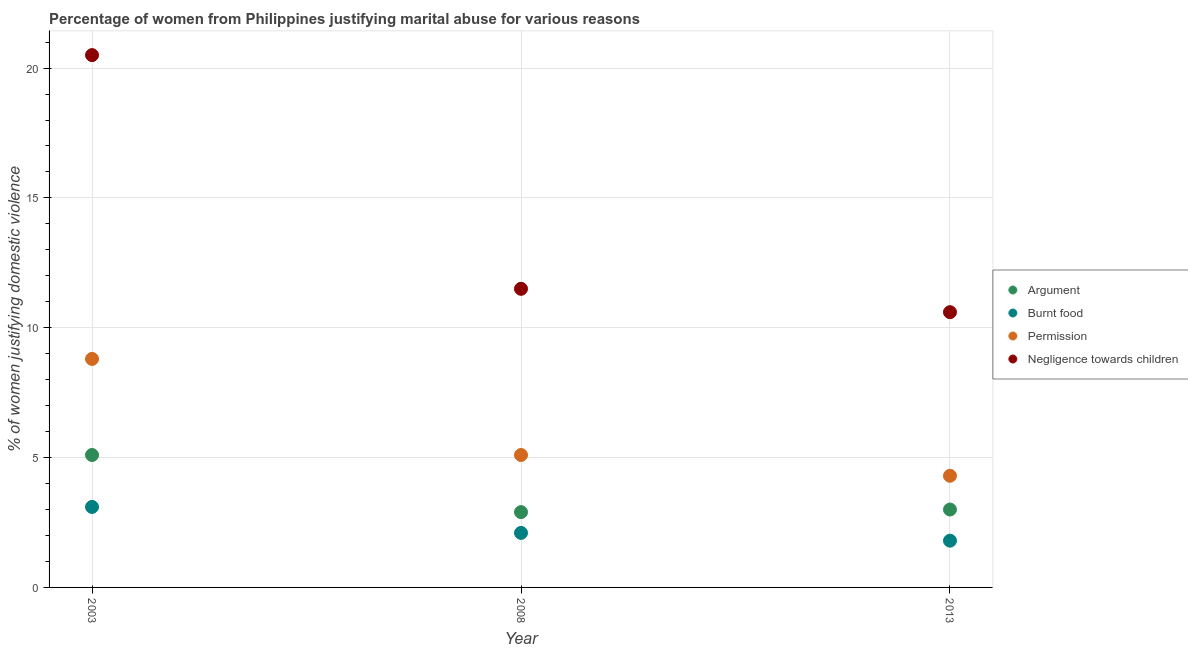What is the percentage of women justifying abuse for going without permission in 2013?
Provide a short and direct response. 4.3. Across all years, what is the maximum percentage of women justifying abuse for showing negligence towards children?
Offer a terse response. 20.5. Across all years, what is the minimum percentage of women justifying abuse in the case of an argument?
Give a very brief answer. 2.9. In which year was the percentage of women justifying abuse for burning food maximum?
Offer a very short reply. 2003. In which year was the percentage of women justifying abuse in the case of an argument minimum?
Ensure brevity in your answer.  2008. What is the total percentage of women justifying abuse for showing negligence towards children in the graph?
Provide a succinct answer. 42.6. What is the difference between the percentage of women justifying abuse for showing negligence towards children in 2008 and that in 2013?
Keep it short and to the point. 0.9. What is the difference between the percentage of women justifying abuse for showing negligence towards children in 2003 and the percentage of women justifying abuse for going without permission in 2008?
Offer a very short reply. 15.4. What is the average percentage of women justifying abuse in the case of an argument per year?
Ensure brevity in your answer.  3.67. In the year 2003, what is the difference between the percentage of women justifying abuse for going without permission and percentage of women justifying abuse for burning food?
Provide a succinct answer. 5.7. What is the ratio of the percentage of women justifying abuse for burning food in 2003 to that in 2008?
Offer a very short reply. 1.48. Is the percentage of women justifying abuse for going without permission in 2003 less than that in 2008?
Make the answer very short. No. Is the difference between the percentage of women justifying abuse for going without permission in 2008 and 2013 greater than the difference between the percentage of women justifying abuse in the case of an argument in 2008 and 2013?
Offer a very short reply. Yes. Is the sum of the percentage of women justifying abuse for showing negligence towards children in 2003 and 2008 greater than the maximum percentage of women justifying abuse for going without permission across all years?
Your answer should be compact. Yes. Is it the case that in every year, the sum of the percentage of women justifying abuse in the case of an argument and percentage of women justifying abuse for burning food is greater than the percentage of women justifying abuse for going without permission?
Keep it short and to the point. No. Does the percentage of women justifying abuse for burning food monotonically increase over the years?
Your response must be concise. No. Are the values on the major ticks of Y-axis written in scientific E-notation?
Give a very brief answer. No. Does the graph contain any zero values?
Your response must be concise. No. Where does the legend appear in the graph?
Make the answer very short. Center right. How many legend labels are there?
Provide a short and direct response. 4. What is the title of the graph?
Make the answer very short. Percentage of women from Philippines justifying marital abuse for various reasons. Does "Budget management" appear as one of the legend labels in the graph?
Your answer should be compact. No. What is the label or title of the X-axis?
Your answer should be compact. Year. What is the label or title of the Y-axis?
Ensure brevity in your answer.  % of women justifying domestic violence. What is the % of women justifying domestic violence in Argument in 2003?
Make the answer very short. 5.1. What is the % of women justifying domestic violence in Burnt food in 2003?
Provide a short and direct response. 3.1. What is the % of women justifying domestic violence in Argument in 2008?
Provide a succinct answer. 2.9. What is the % of women justifying domestic violence in Burnt food in 2008?
Give a very brief answer. 2.1. What is the % of women justifying domestic violence in Negligence towards children in 2008?
Offer a very short reply. 11.5. What is the % of women justifying domestic violence of Burnt food in 2013?
Offer a terse response. 1.8. Across all years, what is the maximum % of women justifying domestic violence of Argument?
Provide a short and direct response. 5.1. Across all years, what is the maximum % of women justifying domestic violence in Burnt food?
Your answer should be very brief. 3.1. Across all years, what is the maximum % of women justifying domestic violence in Permission?
Your response must be concise. 8.8. Across all years, what is the maximum % of women justifying domestic violence of Negligence towards children?
Your answer should be very brief. 20.5. Across all years, what is the minimum % of women justifying domestic violence of Argument?
Your answer should be very brief. 2.9. Across all years, what is the minimum % of women justifying domestic violence in Permission?
Your answer should be very brief. 4.3. Across all years, what is the minimum % of women justifying domestic violence of Negligence towards children?
Your response must be concise. 10.6. What is the total % of women justifying domestic violence in Argument in the graph?
Offer a very short reply. 11. What is the total % of women justifying domestic violence of Permission in the graph?
Keep it short and to the point. 18.2. What is the total % of women justifying domestic violence of Negligence towards children in the graph?
Keep it short and to the point. 42.6. What is the difference between the % of women justifying domestic violence in Burnt food in 2003 and that in 2008?
Keep it short and to the point. 1. What is the difference between the % of women justifying domestic violence in Permission in 2003 and that in 2008?
Provide a short and direct response. 3.7. What is the difference between the % of women justifying domestic violence in Negligence towards children in 2003 and that in 2008?
Offer a terse response. 9. What is the difference between the % of women justifying domestic violence in Permission in 2003 and that in 2013?
Your response must be concise. 4.5. What is the difference between the % of women justifying domestic violence in Negligence towards children in 2003 and that in 2013?
Ensure brevity in your answer.  9.9. What is the difference between the % of women justifying domestic violence in Argument in 2008 and that in 2013?
Ensure brevity in your answer.  -0.1. What is the difference between the % of women justifying domestic violence of Burnt food in 2008 and that in 2013?
Offer a terse response. 0.3. What is the difference between the % of women justifying domestic violence in Burnt food in 2003 and the % of women justifying domestic violence in Negligence towards children in 2008?
Your answer should be compact. -8.4. What is the difference between the % of women justifying domestic violence in Argument in 2003 and the % of women justifying domestic violence in Burnt food in 2013?
Ensure brevity in your answer.  3.3. What is the difference between the % of women justifying domestic violence in Argument in 2003 and the % of women justifying domestic violence in Permission in 2013?
Give a very brief answer. 0.8. What is the difference between the % of women justifying domestic violence in Argument in 2003 and the % of women justifying domestic violence in Negligence towards children in 2013?
Ensure brevity in your answer.  -5.5. What is the difference between the % of women justifying domestic violence in Burnt food in 2003 and the % of women justifying domestic violence in Permission in 2013?
Give a very brief answer. -1.2. What is the difference between the % of women justifying domestic violence of Argument in 2008 and the % of women justifying domestic violence of Permission in 2013?
Ensure brevity in your answer.  -1.4. What is the difference between the % of women justifying domestic violence of Argument in 2008 and the % of women justifying domestic violence of Negligence towards children in 2013?
Keep it short and to the point. -7.7. What is the difference between the % of women justifying domestic violence in Burnt food in 2008 and the % of women justifying domestic violence in Permission in 2013?
Ensure brevity in your answer.  -2.2. What is the difference between the % of women justifying domestic violence in Burnt food in 2008 and the % of women justifying domestic violence in Negligence towards children in 2013?
Keep it short and to the point. -8.5. What is the difference between the % of women justifying domestic violence of Permission in 2008 and the % of women justifying domestic violence of Negligence towards children in 2013?
Give a very brief answer. -5.5. What is the average % of women justifying domestic violence in Argument per year?
Offer a terse response. 3.67. What is the average % of women justifying domestic violence in Burnt food per year?
Offer a terse response. 2.33. What is the average % of women justifying domestic violence of Permission per year?
Provide a succinct answer. 6.07. In the year 2003, what is the difference between the % of women justifying domestic violence in Argument and % of women justifying domestic violence in Burnt food?
Ensure brevity in your answer.  2. In the year 2003, what is the difference between the % of women justifying domestic violence in Argument and % of women justifying domestic violence in Negligence towards children?
Your answer should be very brief. -15.4. In the year 2003, what is the difference between the % of women justifying domestic violence of Burnt food and % of women justifying domestic violence of Negligence towards children?
Your answer should be compact. -17.4. In the year 2003, what is the difference between the % of women justifying domestic violence in Permission and % of women justifying domestic violence in Negligence towards children?
Your response must be concise. -11.7. In the year 2008, what is the difference between the % of women justifying domestic violence in Burnt food and % of women justifying domestic violence in Permission?
Give a very brief answer. -3. In the year 2008, what is the difference between the % of women justifying domestic violence of Burnt food and % of women justifying domestic violence of Negligence towards children?
Provide a succinct answer. -9.4. In the year 2013, what is the difference between the % of women justifying domestic violence of Argument and % of women justifying domestic violence of Burnt food?
Your answer should be very brief. 1.2. In the year 2013, what is the difference between the % of women justifying domestic violence in Argument and % of women justifying domestic violence in Negligence towards children?
Make the answer very short. -7.6. In the year 2013, what is the difference between the % of women justifying domestic violence of Burnt food and % of women justifying domestic violence of Negligence towards children?
Provide a short and direct response. -8.8. What is the ratio of the % of women justifying domestic violence in Argument in 2003 to that in 2008?
Offer a very short reply. 1.76. What is the ratio of the % of women justifying domestic violence of Burnt food in 2003 to that in 2008?
Your answer should be compact. 1.48. What is the ratio of the % of women justifying domestic violence of Permission in 2003 to that in 2008?
Keep it short and to the point. 1.73. What is the ratio of the % of women justifying domestic violence in Negligence towards children in 2003 to that in 2008?
Your response must be concise. 1.78. What is the ratio of the % of women justifying domestic violence in Argument in 2003 to that in 2013?
Provide a succinct answer. 1.7. What is the ratio of the % of women justifying domestic violence in Burnt food in 2003 to that in 2013?
Offer a very short reply. 1.72. What is the ratio of the % of women justifying domestic violence in Permission in 2003 to that in 2013?
Give a very brief answer. 2.05. What is the ratio of the % of women justifying domestic violence in Negligence towards children in 2003 to that in 2013?
Give a very brief answer. 1.93. What is the ratio of the % of women justifying domestic violence in Argument in 2008 to that in 2013?
Offer a terse response. 0.97. What is the ratio of the % of women justifying domestic violence of Burnt food in 2008 to that in 2013?
Your response must be concise. 1.17. What is the ratio of the % of women justifying domestic violence in Permission in 2008 to that in 2013?
Your answer should be very brief. 1.19. What is the ratio of the % of women justifying domestic violence of Negligence towards children in 2008 to that in 2013?
Ensure brevity in your answer.  1.08. What is the difference between the highest and the second highest % of women justifying domestic violence in Burnt food?
Your response must be concise. 1. What is the difference between the highest and the second highest % of women justifying domestic violence in Permission?
Make the answer very short. 3.7. What is the difference between the highest and the second highest % of women justifying domestic violence of Negligence towards children?
Make the answer very short. 9. 